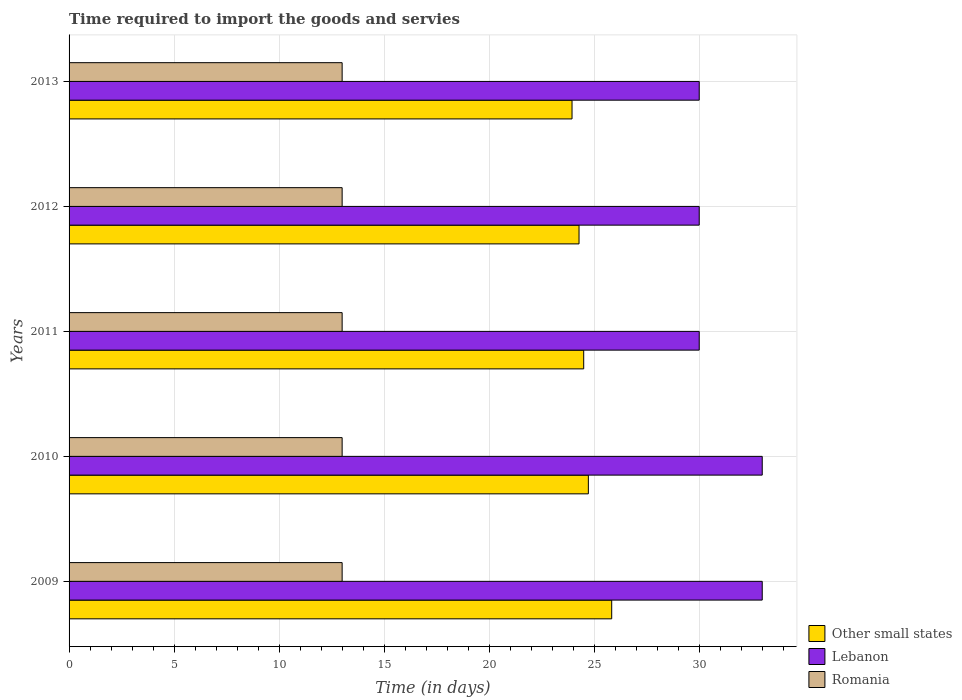How many different coloured bars are there?
Give a very brief answer. 3. Are the number of bars per tick equal to the number of legend labels?
Provide a succinct answer. Yes. Are the number of bars on each tick of the Y-axis equal?
Offer a terse response. Yes. How many bars are there on the 2nd tick from the bottom?
Provide a short and direct response. 3. What is the number of days required to import the goods and services in Lebanon in 2011?
Give a very brief answer. 30. Across all years, what is the maximum number of days required to import the goods and services in Romania?
Provide a succinct answer. 13. Across all years, what is the minimum number of days required to import the goods and services in Lebanon?
Your answer should be very brief. 30. What is the total number of days required to import the goods and services in Lebanon in the graph?
Make the answer very short. 156. What is the difference between the number of days required to import the goods and services in Lebanon in 2009 and that in 2013?
Offer a terse response. 3. What is the difference between the number of days required to import the goods and services in Lebanon in 2011 and the number of days required to import the goods and services in Romania in 2012?
Make the answer very short. 17. What is the average number of days required to import the goods and services in Other small states per year?
Offer a terse response. 24.66. In the year 2013, what is the difference between the number of days required to import the goods and services in Romania and number of days required to import the goods and services in Other small states?
Your response must be concise. -10.94. In how many years, is the number of days required to import the goods and services in Romania greater than 18 days?
Your answer should be very brief. 0. Is the number of days required to import the goods and services in Other small states in 2011 less than that in 2012?
Your answer should be very brief. No. What is the difference between the highest and the second highest number of days required to import the goods and services in Lebanon?
Offer a very short reply. 0. What is the difference between the highest and the lowest number of days required to import the goods and services in Other small states?
Offer a terse response. 1.89. What does the 3rd bar from the top in 2011 represents?
Ensure brevity in your answer.  Other small states. What does the 1st bar from the bottom in 2011 represents?
Your answer should be compact. Other small states. Is it the case that in every year, the sum of the number of days required to import the goods and services in Lebanon and number of days required to import the goods and services in Romania is greater than the number of days required to import the goods and services in Other small states?
Keep it short and to the point. Yes. Are all the bars in the graph horizontal?
Provide a short and direct response. Yes. How many years are there in the graph?
Offer a very short reply. 5. Are the values on the major ticks of X-axis written in scientific E-notation?
Your answer should be compact. No. Does the graph contain any zero values?
Your response must be concise. No. What is the title of the graph?
Your answer should be very brief. Time required to import the goods and servies. Does "Liberia" appear as one of the legend labels in the graph?
Offer a very short reply. No. What is the label or title of the X-axis?
Your answer should be very brief. Time (in days). What is the label or title of the Y-axis?
Keep it short and to the point. Years. What is the Time (in days) of Other small states in 2009?
Your answer should be compact. 25.83. What is the Time (in days) in Lebanon in 2009?
Your response must be concise. 33. What is the Time (in days) in Romania in 2009?
Your answer should be very brief. 13. What is the Time (in days) in Other small states in 2010?
Keep it short and to the point. 24.72. What is the Time (in days) in Lebanon in 2010?
Your response must be concise. 33. What is the Time (in days) of Romania in 2010?
Make the answer very short. 13. What is the Time (in days) of Other small states in 2011?
Ensure brevity in your answer.  24.5. What is the Time (in days) in Other small states in 2012?
Provide a succinct answer. 24.28. What is the Time (in days) in Lebanon in 2012?
Offer a terse response. 30. What is the Time (in days) of Romania in 2012?
Ensure brevity in your answer.  13. What is the Time (in days) of Other small states in 2013?
Give a very brief answer. 23.94. What is the Time (in days) in Lebanon in 2013?
Offer a very short reply. 30. What is the Time (in days) of Romania in 2013?
Provide a succinct answer. 13. Across all years, what is the maximum Time (in days) in Other small states?
Your response must be concise. 25.83. Across all years, what is the minimum Time (in days) of Other small states?
Provide a short and direct response. 23.94. What is the total Time (in days) of Other small states in the graph?
Offer a terse response. 123.28. What is the total Time (in days) in Lebanon in the graph?
Make the answer very short. 156. What is the total Time (in days) in Romania in the graph?
Provide a short and direct response. 65. What is the difference between the Time (in days) of Lebanon in 2009 and that in 2010?
Provide a short and direct response. 0. What is the difference between the Time (in days) of Romania in 2009 and that in 2010?
Make the answer very short. 0. What is the difference between the Time (in days) of Lebanon in 2009 and that in 2011?
Provide a succinct answer. 3. What is the difference between the Time (in days) of Romania in 2009 and that in 2011?
Your response must be concise. 0. What is the difference between the Time (in days) of Other small states in 2009 and that in 2012?
Offer a terse response. 1.56. What is the difference between the Time (in days) in Romania in 2009 and that in 2012?
Offer a terse response. 0. What is the difference between the Time (in days) of Other small states in 2009 and that in 2013?
Your answer should be very brief. 1.89. What is the difference between the Time (in days) in Other small states in 2010 and that in 2011?
Keep it short and to the point. 0.22. What is the difference between the Time (in days) in Romania in 2010 and that in 2011?
Your answer should be compact. 0. What is the difference between the Time (in days) in Other small states in 2010 and that in 2012?
Offer a terse response. 0.44. What is the difference between the Time (in days) of Other small states in 2010 and that in 2013?
Provide a succinct answer. 0.78. What is the difference between the Time (in days) in Lebanon in 2010 and that in 2013?
Your answer should be very brief. 3. What is the difference between the Time (in days) in Romania in 2010 and that in 2013?
Offer a very short reply. 0. What is the difference between the Time (in days) in Other small states in 2011 and that in 2012?
Offer a very short reply. 0.22. What is the difference between the Time (in days) of Lebanon in 2011 and that in 2012?
Your response must be concise. 0. What is the difference between the Time (in days) in Romania in 2011 and that in 2012?
Your answer should be very brief. 0. What is the difference between the Time (in days) of Other small states in 2011 and that in 2013?
Offer a terse response. 0.56. What is the difference between the Time (in days) in Lebanon in 2011 and that in 2013?
Make the answer very short. 0. What is the difference between the Time (in days) in Lebanon in 2012 and that in 2013?
Your answer should be compact. 0. What is the difference between the Time (in days) of Romania in 2012 and that in 2013?
Provide a short and direct response. 0. What is the difference between the Time (in days) of Other small states in 2009 and the Time (in days) of Lebanon in 2010?
Give a very brief answer. -7.17. What is the difference between the Time (in days) of Other small states in 2009 and the Time (in days) of Romania in 2010?
Your answer should be very brief. 12.83. What is the difference between the Time (in days) in Lebanon in 2009 and the Time (in days) in Romania in 2010?
Offer a very short reply. 20. What is the difference between the Time (in days) of Other small states in 2009 and the Time (in days) of Lebanon in 2011?
Offer a very short reply. -4.17. What is the difference between the Time (in days) in Other small states in 2009 and the Time (in days) in Romania in 2011?
Ensure brevity in your answer.  12.83. What is the difference between the Time (in days) in Lebanon in 2009 and the Time (in days) in Romania in 2011?
Your answer should be compact. 20. What is the difference between the Time (in days) of Other small states in 2009 and the Time (in days) of Lebanon in 2012?
Make the answer very short. -4.17. What is the difference between the Time (in days) in Other small states in 2009 and the Time (in days) in Romania in 2012?
Your answer should be very brief. 12.83. What is the difference between the Time (in days) of Lebanon in 2009 and the Time (in days) of Romania in 2012?
Your answer should be compact. 20. What is the difference between the Time (in days) of Other small states in 2009 and the Time (in days) of Lebanon in 2013?
Provide a short and direct response. -4.17. What is the difference between the Time (in days) in Other small states in 2009 and the Time (in days) in Romania in 2013?
Keep it short and to the point. 12.83. What is the difference between the Time (in days) in Other small states in 2010 and the Time (in days) in Lebanon in 2011?
Provide a short and direct response. -5.28. What is the difference between the Time (in days) in Other small states in 2010 and the Time (in days) in Romania in 2011?
Give a very brief answer. 11.72. What is the difference between the Time (in days) of Lebanon in 2010 and the Time (in days) of Romania in 2011?
Make the answer very short. 20. What is the difference between the Time (in days) of Other small states in 2010 and the Time (in days) of Lebanon in 2012?
Offer a very short reply. -5.28. What is the difference between the Time (in days) in Other small states in 2010 and the Time (in days) in Romania in 2012?
Provide a short and direct response. 11.72. What is the difference between the Time (in days) in Lebanon in 2010 and the Time (in days) in Romania in 2012?
Give a very brief answer. 20. What is the difference between the Time (in days) in Other small states in 2010 and the Time (in days) in Lebanon in 2013?
Keep it short and to the point. -5.28. What is the difference between the Time (in days) of Other small states in 2010 and the Time (in days) of Romania in 2013?
Provide a short and direct response. 11.72. What is the difference between the Time (in days) of Lebanon in 2010 and the Time (in days) of Romania in 2013?
Your answer should be very brief. 20. What is the difference between the Time (in days) of Other small states in 2011 and the Time (in days) of Lebanon in 2013?
Provide a succinct answer. -5.5. What is the difference between the Time (in days) of Lebanon in 2011 and the Time (in days) of Romania in 2013?
Provide a succinct answer. 17. What is the difference between the Time (in days) in Other small states in 2012 and the Time (in days) in Lebanon in 2013?
Ensure brevity in your answer.  -5.72. What is the difference between the Time (in days) of Other small states in 2012 and the Time (in days) of Romania in 2013?
Your answer should be compact. 11.28. What is the difference between the Time (in days) in Lebanon in 2012 and the Time (in days) in Romania in 2013?
Keep it short and to the point. 17. What is the average Time (in days) in Other small states per year?
Ensure brevity in your answer.  24.66. What is the average Time (in days) in Lebanon per year?
Provide a succinct answer. 31.2. In the year 2009, what is the difference between the Time (in days) in Other small states and Time (in days) in Lebanon?
Your response must be concise. -7.17. In the year 2009, what is the difference between the Time (in days) of Other small states and Time (in days) of Romania?
Ensure brevity in your answer.  12.83. In the year 2009, what is the difference between the Time (in days) in Lebanon and Time (in days) in Romania?
Offer a terse response. 20. In the year 2010, what is the difference between the Time (in days) of Other small states and Time (in days) of Lebanon?
Ensure brevity in your answer.  -8.28. In the year 2010, what is the difference between the Time (in days) of Other small states and Time (in days) of Romania?
Offer a very short reply. 11.72. In the year 2010, what is the difference between the Time (in days) in Lebanon and Time (in days) in Romania?
Offer a terse response. 20. In the year 2011, what is the difference between the Time (in days) in Other small states and Time (in days) in Romania?
Offer a terse response. 11.5. In the year 2012, what is the difference between the Time (in days) of Other small states and Time (in days) of Lebanon?
Give a very brief answer. -5.72. In the year 2012, what is the difference between the Time (in days) in Other small states and Time (in days) in Romania?
Your answer should be compact. 11.28. In the year 2013, what is the difference between the Time (in days) in Other small states and Time (in days) in Lebanon?
Keep it short and to the point. -6.06. In the year 2013, what is the difference between the Time (in days) of Other small states and Time (in days) of Romania?
Make the answer very short. 10.94. What is the ratio of the Time (in days) of Other small states in 2009 to that in 2010?
Keep it short and to the point. 1.04. What is the ratio of the Time (in days) in Lebanon in 2009 to that in 2010?
Provide a short and direct response. 1. What is the ratio of the Time (in days) of Other small states in 2009 to that in 2011?
Ensure brevity in your answer.  1.05. What is the ratio of the Time (in days) in Other small states in 2009 to that in 2012?
Offer a terse response. 1.06. What is the ratio of the Time (in days) of Romania in 2009 to that in 2012?
Keep it short and to the point. 1. What is the ratio of the Time (in days) in Other small states in 2009 to that in 2013?
Offer a terse response. 1.08. What is the ratio of the Time (in days) in Romania in 2009 to that in 2013?
Offer a very short reply. 1. What is the ratio of the Time (in days) in Other small states in 2010 to that in 2011?
Make the answer very short. 1.01. What is the ratio of the Time (in days) in Other small states in 2010 to that in 2012?
Keep it short and to the point. 1.02. What is the ratio of the Time (in days) of Other small states in 2010 to that in 2013?
Your answer should be very brief. 1.03. What is the ratio of the Time (in days) in Lebanon in 2010 to that in 2013?
Provide a short and direct response. 1.1. What is the ratio of the Time (in days) of Other small states in 2011 to that in 2012?
Offer a terse response. 1.01. What is the ratio of the Time (in days) in Lebanon in 2011 to that in 2012?
Your answer should be compact. 1. What is the ratio of the Time (in days) of Romania in 2011 to that in 2012?
Keep it short and to the point. 1. What is the ratio of the Time (in days) of Other small states in 2011 to that in 2013?
Keep it short and to the point. 1.02. What is the ratio of the Time (in days) of Lebanon in 2011 to that in 2013?
Ensure brevity in your answer.  1. What is the ratio of the Time (in days) of Romania in 2011 to that in 2013?
Your answer should be compact. 1. What is the ratio of the Time (in days) of Other small states in 2012 to that in 2013?
Give a very brief answer. 1.01. What is the ratio of the Time (in days) of Lebanon in 2012 to that in 2013?
Your response must be concise. 1. What is the difference between the highest and the second highest Time (in days) of Other small states?
Make the answer very short. 1.11. What is the difference between the highest and the second highest Time (in days) in Lebanon?
Your response must be concise. 0. What is the difference between the highest and the lowest Time (in days) of Other small states?
Your answer should be compact. 1.89. What is the difference between the highest and the lowest Time (in days) in Lebanon?
Your response must be concise. 3. 